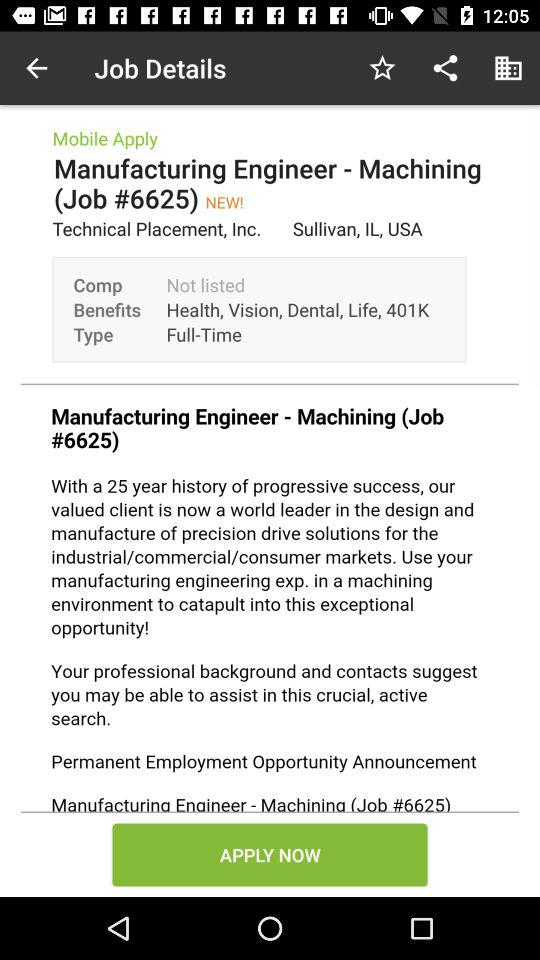What is the job ID? The job ID is #6625. 